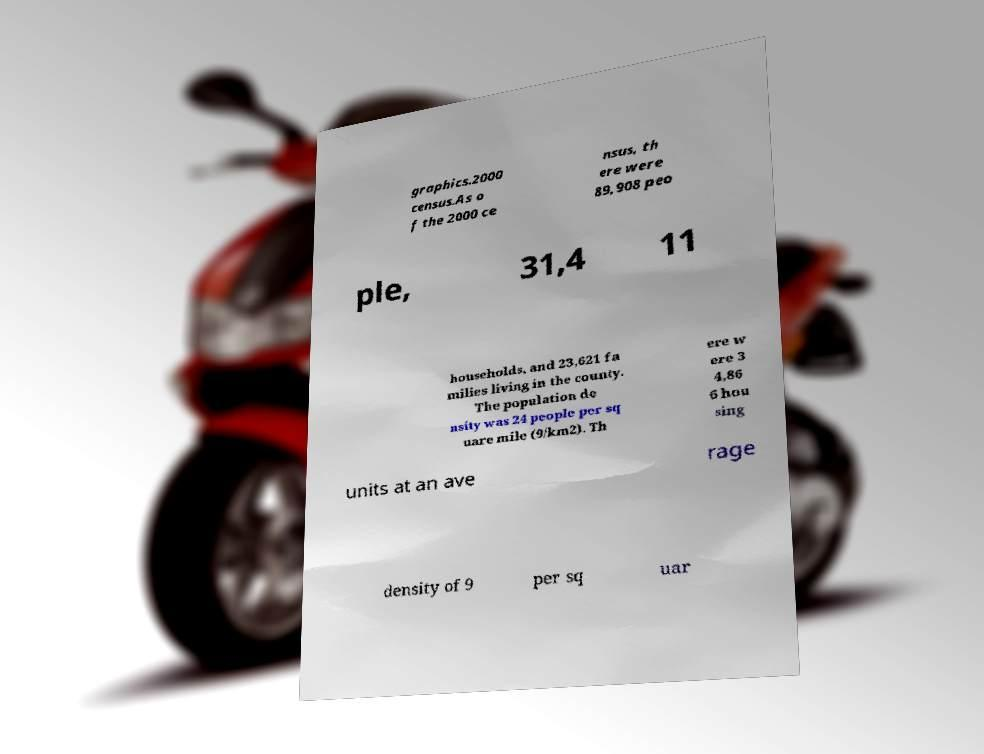Please read and relay the text visible in this image. What does it say? graphics.2000 census.As o f the 2000 ce nsus, th ere were 89,908 peo ple, 31,4 11 households, and 23,621 fa milies living in the county. The population de nsity was 24 people per sq uare mile (9/km2). Th ere w ere 3 4,86 6 hou sing units at an ave rage density of 9 per sq uar 